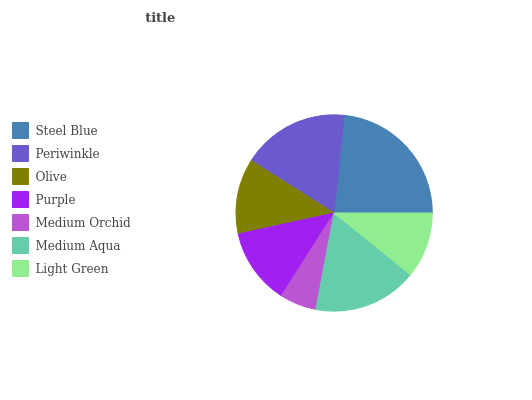Is Medium Orchid the minimum?
Answer yes or no. Yes. Is Steel Blue the maximum?
Answer yes or no. Yes. Is Periwinkle the minimum?
Answer yes or no. No. Is Periwinkle the maximum?
Answer yes or no. No. Is Steel Blue greater than Periwinkle?
Answer yes or no. Yes. Is Periwinkle less than Steel Blue?
Answer yes or no. Yes. Is Periwinkle greater than Steel Blue?
Answer yes or no. No. Is Steel Blue less than Periwinkle?
Answer yes or no. No. Is Purple the high median?
Answer yes or no. Yes. Is Purple the low median?
Answer yes or no. Yes. Is Olive the high median?
Answer yes or no. No. Is Periwinkle the low median?
Answer yes or no. No. 